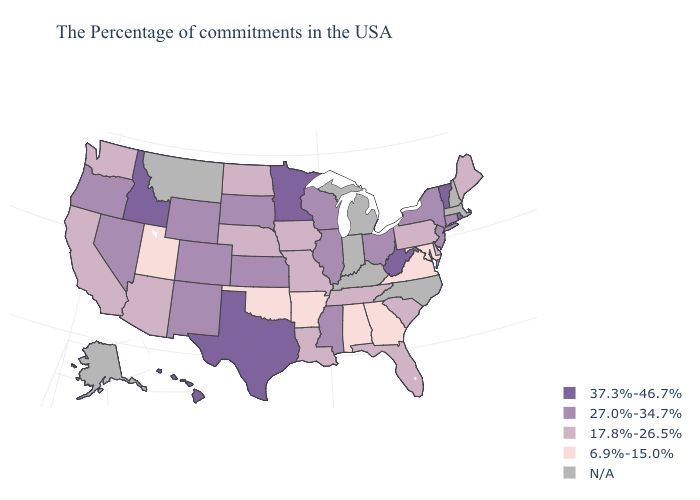What is the lowest value in the USA?
Give a very brief answer. 6.9%-15.0%. What is the value of New Jersey?
Concise answer only. 27.0%-34.7%. What is the lowest value in the South?
Quick response, please. 6.9%-15.0%. What is the highest value in the West ?
Be succinct. 37.3%-46.7%. What is the lowest value in the West?
Be succinct. 6.9%-15.0%. What is the lowest value in states that border New Jersey?
Write a very short answer. 17.8%-26.5%. Name the states that have a value in the range 17.8%-26.5%?
Quick response, please. Maine, Delaware, Pennsylvania, South Carolina, Florida, Tennessee, Louisiana, Missouri, Iowa, Nebraska, North Dakota, Arizona, California, Washington. What is the value of Massachusetts?
Keep it brief. N/A. What is the value of Kansas?
Write a very short answer. 27.0%-34.7%. Among the states that border Iowa , does South Dakota have the lowest value?
Give a very brief answer. No. Name the states that have a value in the range 6.9%-15.0%?
Give a very brief answer. Maryland, Virginia, Georgia, Alabama, Arkansas, Oklahoma, Utah. What is the value of Indiana?
Write a very short answer. N/A. Name the states that have a value in the range 37.3%-46.7%?
Answer briefly. Rhode Island, Vermont, West Virginia, Minnesota, Texas, Idaho, Hawaii. What is the highest value in states that border Rhode Island?
Keep it brief. 27.0%-34.7%. 